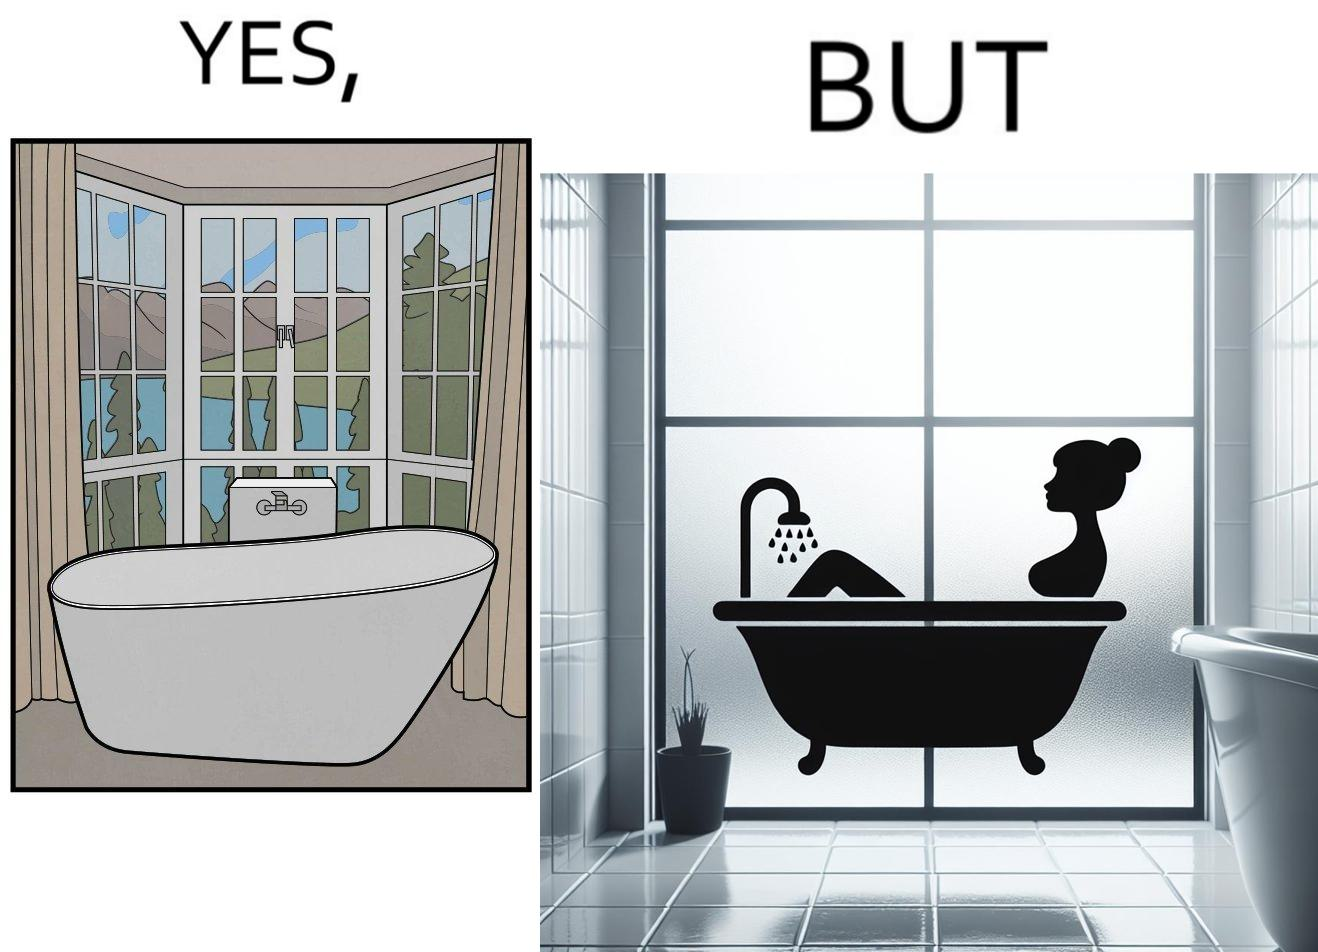Provide a description of this image. The image is ironical, as a bathtub near a window having a very scenic view, becomes misty when someone is bathing, thus making the scenic view blurry. 